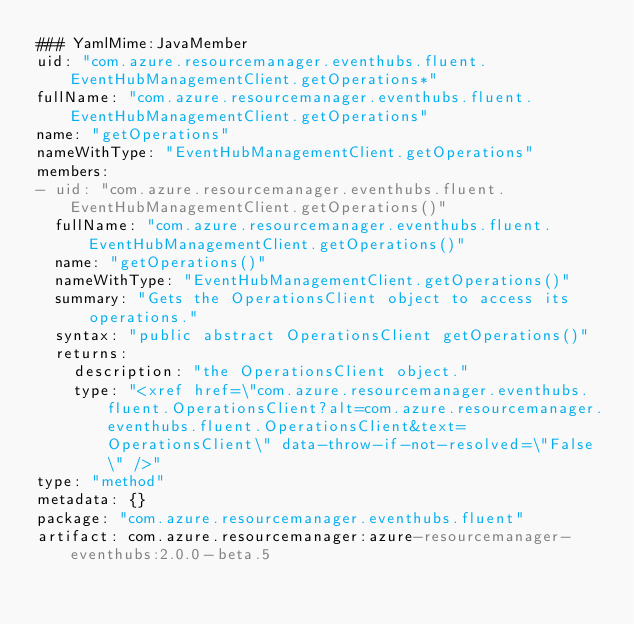Convert code to text. <code><loc_0><loc_0><loc_500><loc_500><_YAML_>### YamlMime:JavaMember
uid: "com.azure.resourcemanager.eventhubs.fluent.EventHubManagementClient.getOperations*"
fullName: "com.azure.resourcemanager.eventhubs.fluent.EventHubManagementClient.getOperations"
name: "getOperations"
nameWithType: "EventHubManagementClient.getOperations"
members:
- uid: "com.azure.resourcemanager.eventhubs.fluent.EventHubManagementClient.getOperations()"
  fullName: "com.azure.resourcemanager.eventhubs.fluent.EventHubManagementClient.getOperations()"
  name: "getOperations()"
  nameWithType: "EventHubManagementClient.getOperations()"
  summary: "Gets the OperationsClient object to access its operations."
  syntax: "public abstract OperationsClient getOperations()"
  returns:
    description: "the OperationsClient object."
    type: "<xref href=\"com.azure.resourcemanager.eventhubs.fluent.OperationsClient?alt=com.azure.resourcemanager.eventhubs.fluent.OperationsClient&text=OperationsClient\" data-throw-if-not-resolved=\"False\" />"
type: "method"
metadata: {}
package: "com.azure.resourcemanager.eventhubs.fluent"
artifact: com.azure.resourcemanager:azure-resourcemanager-eventhubs:2.0.0-beta.5
</code> 